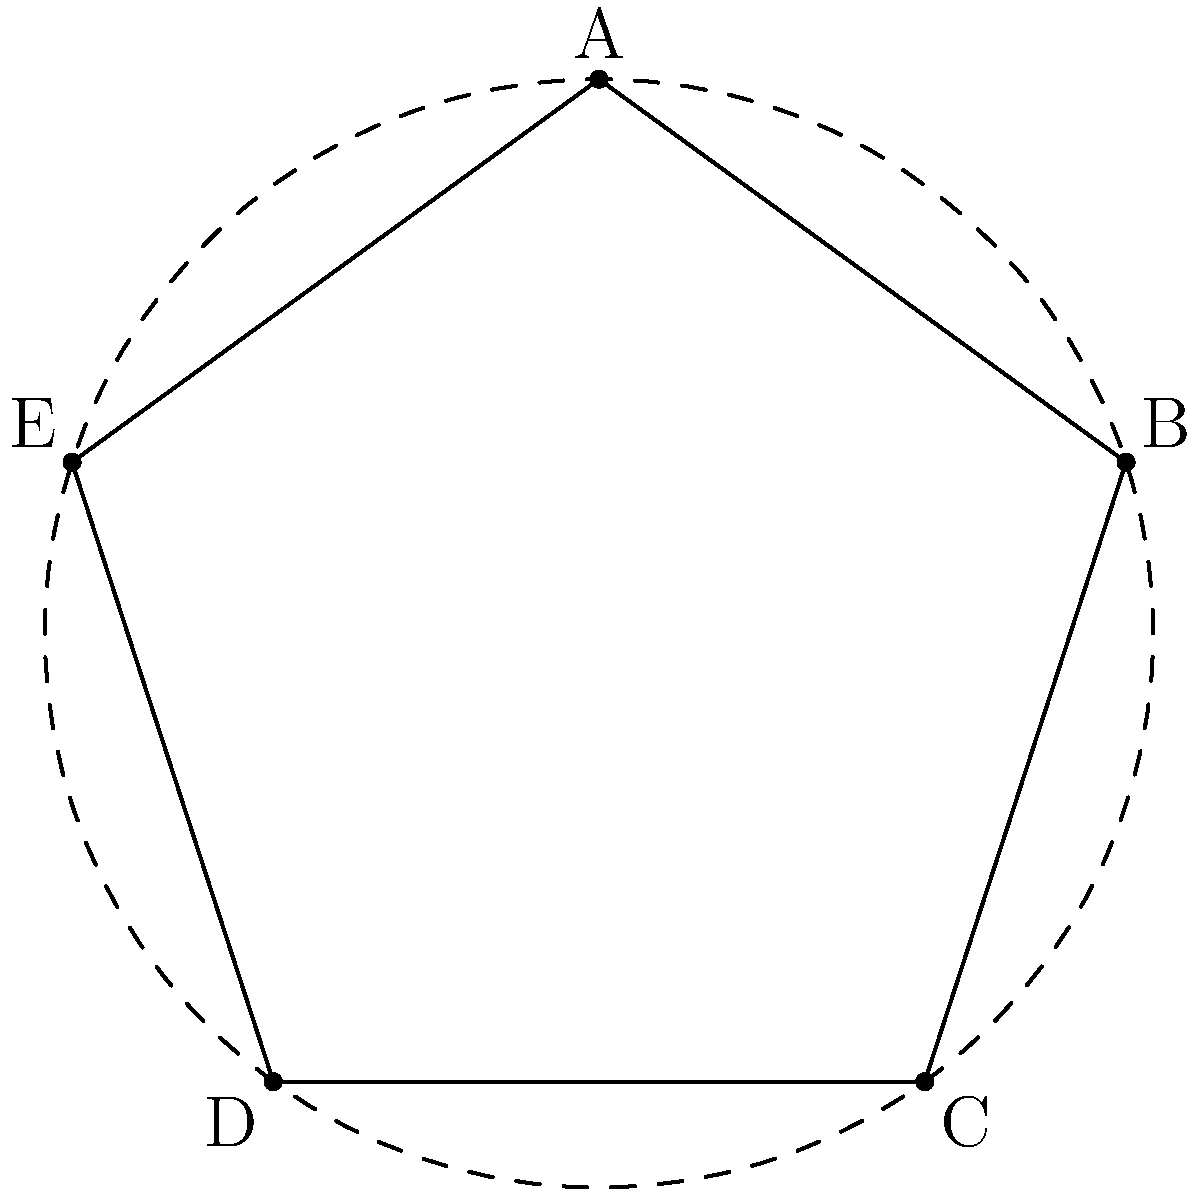Consider the symmetry group of a regular pentagon, $D_5$. How many subgroups of order 2 does $D_5$ have? To determine the number of subgroups of order 2 in $D_5$, let's follow these steps:

1. Recall that $D_5$ has order 10 and contains rotations and reflections.

2. The elements of $D_5$ are:
   - Identity (1)
   - Rotations: $r$, $r^2$, $r^3$, $r^4$ (where $r$ is a rotation by 72°)
   - Reflections: 5 reflections, one across each vertex

3. Subgroups of order 2 must contain the identity and one other element of order 2.

4. In $D_5$, elements of order 2 are:
   - All 5 reflections
   - The rotation $r^5$ (360° rotation, which is the identity)

5. Each reflection forms a subgroup of order 2 with the identity.

6. The rotation $r^5$ is already the identity, so it doesn't form a distinct subgroup.

7. Therefore, there are 5 subgroups of order 2, each containing the identity and one of the 5 reflections.

This result aligns with the fact that in $D_n$, there are always $n$ subgroups of order 2, corresponding to the $n$ axes of symmetry in a regular $n$-gon.
Answer: 5 